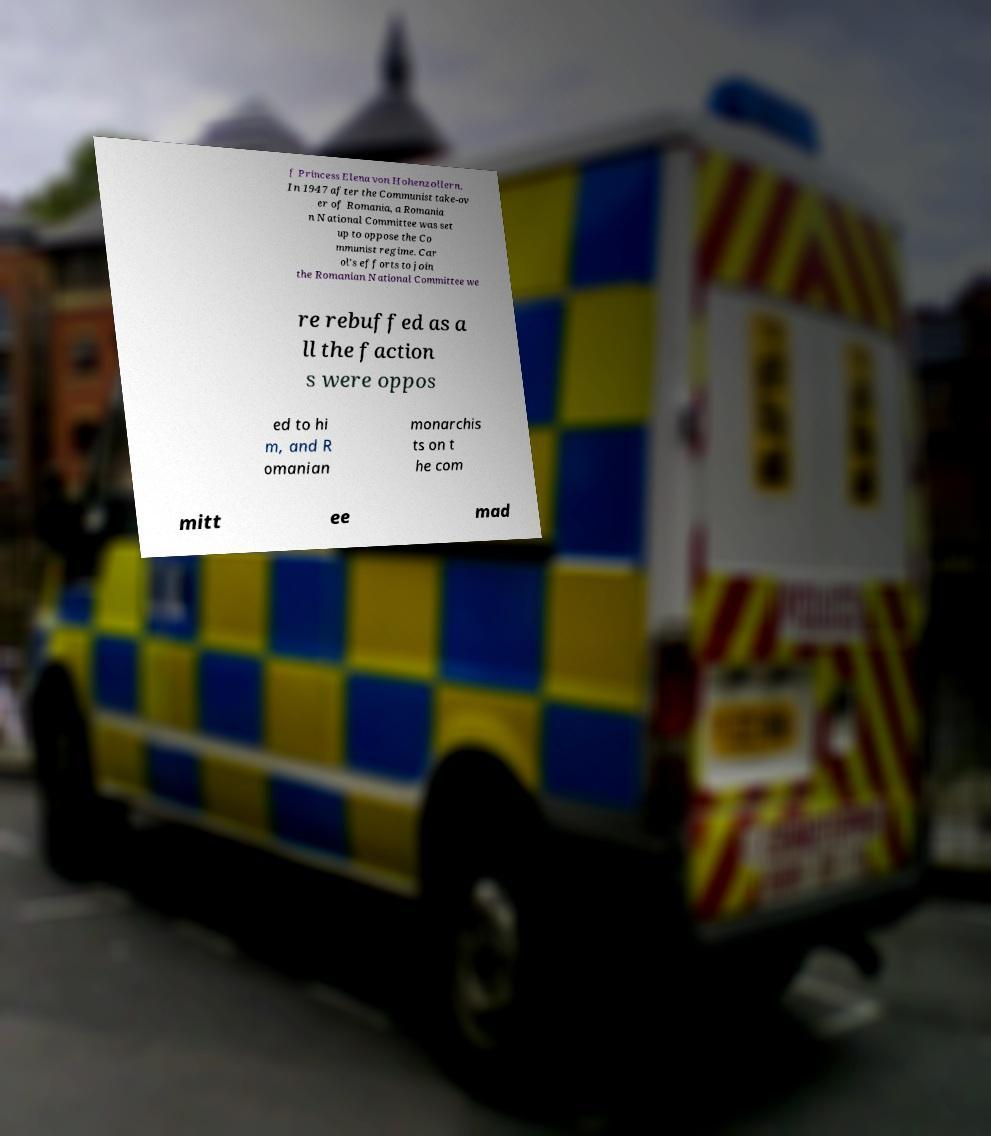Could you extract and type out the text from this image? f Princess Elena von Hohenzollern. In 1947 after the Communist take-ov er of Romania, a Romania n National Committee was set up to oppose the Co mmunist regime. Car ol's efforts to join the Romanian National Committee we re rebuffed as a ll the faction s were oppos ed to hi m, and R omanian monarchis ts on t he com mitt ee mad 